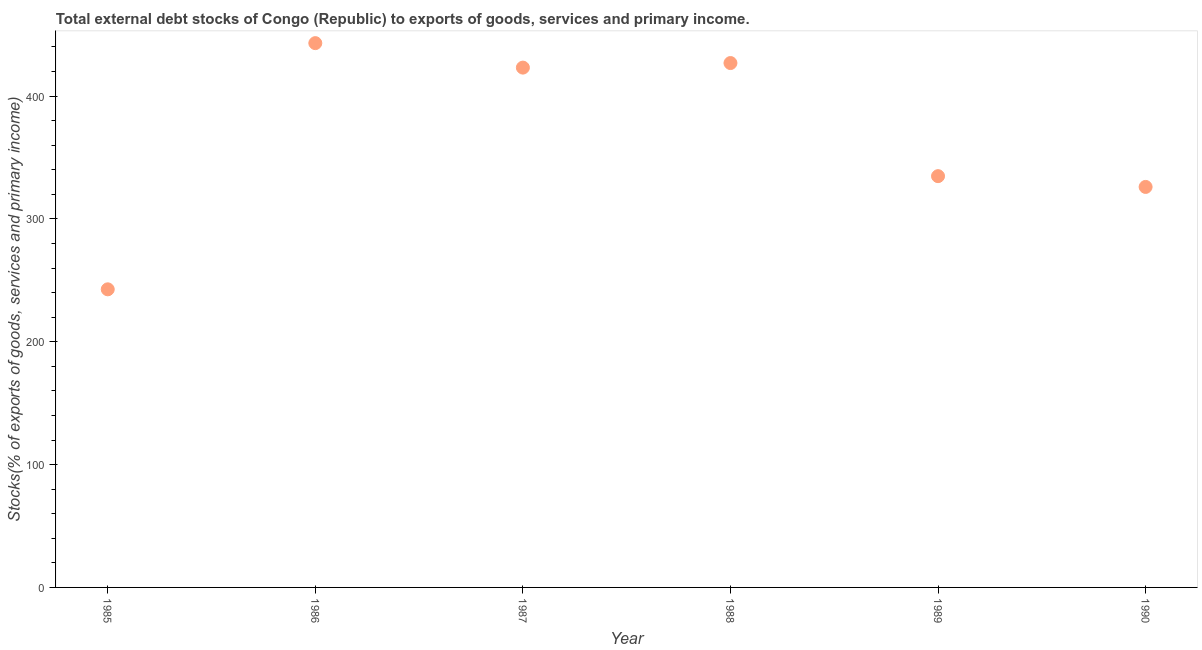What is the external debt stocks in 1990?
Your answer should be very brief. 326.01. Across all years, what is the maximum external debt stocks?
Your answer should be compact. 443.06. Across all years, what is the minimum external debt stocks?
Ensure brevity in your answer.  242.66. In which year was the external debt stocks maximum?
Offer a terse response. 1986. What is the sum of the external debt stocks?
Offer a terse response. 2196.49. What is the difference between the external debt stocks in 1987 and 1988?
Your answer should be compact. -3.71. What is the average external debt stocks per year?
Your response must be concise. 366.08. What is the median external debt stocks?
Keep it short and to the point. 378.96. In how many years, is the external debt stocks greater than 320 %?
Make the answer very short. 5. Do a majority of the years between 1987 and 1985 (inclusive) have external debt stocks greater than 280 %?
Make the answer very short. No. What is the ratio of the external debt stocks in 1986 to that in 1988?
Provide a short and direct response. 1.04. Is the external debt stocks in 1987 less than that in 1988?
Give a very brief answer. Yes. Is the difference between the external debt stocks in 1986 and 1988 greater than the difference between any two years?
Your answer should be compact. No. What is the difference between the highest and the second highest external debt stocks?
Provide a succinct answer. 16.21. What is the difference between the highest and the lowest external debt stocks?
Provide a succinct answer. 200.4. In how many years, is the external debt stocks greater than the average external debt stocks taken over all years?
Provide a short and direct response. 3. How many dotlines are there?
Offer a terse response. 1. What is the difference between two consecutive major ticks on the Y-axis?
Keep it short and to the point. 100. Are the values on the major ticks of Y-axis written in scientific E-notation?
Ensure brevity in your answer.  No. Does the graph contain grids?
Keep it short and to the point. No. What is the title of the graph?
Ensure brevity in your answer.  Total external debt stocks of Congo (Republic) to exports of goods, services and primary income. What is the label or title of the Y-axis?
Offer a terse response. Stocks(% of exports of goods, services and primary income). What is the Stocks(% of exports of goods, services and primary income) in 1985?
Your answer should be compact. 242.66. What is the Stocks(% of exports of goods, services and primary income) in 1986?
Your response must be concise. 443.06. What is the Stocks(% of exports of goods, services and primary income) in 1987?
Offer a terse response. 423.14. What is the Stocks(% of exports of goods, services and primary income) in 1988?
Provide a short and direct response. 426.85. What is the Stocks(% of exports of goods, services and primary income) in 1989?
Give a very brief answer. 334.79. What is the Stocks(% of exports of goods, services and primary income) in 1990?
Your answer should be compact. 326.01. What is the difference between the Stocks(% of exports of goods, services and primary income) in 1985 and 1986?
Your answer should be compact. -200.4. What is the difference between the Stocks(% of exports of goods, services and primary income) in 1985 and 1987?
Provide a short and direct response. -180.48. What is the difference between the Stocks(% of exports of goods, services and primary income) in 1985 and 1988?
Keep it short and to the point. -184.19. What is the difference between the Stocks(% of exports of goods, services and primary income) in 1985 and 1989?
Give a very brief answer. -92.13. What is the difference between the Stocks(% of exports of goods, services and primary income) in 1985 and 1990?
Keep it short and to the point. -83.35. What is the difference between the Stocks(% of exports of goods, services and primary income) in 1986 and 1987?
Your answer should be compact. 19.92. What is the difference between the Stocks(% of exports of goods, services and primary income) in 1986 and 1988?
Your answer should be compact. 16.21. What is the difference between the Stocks(% of exports of goods, services and primary income) in 1986 and 1989?
Ensure brevity in your answer.  108.27. What is the difference between the Stocks(% of exports of goods, services and primary income) in 1986 and 1990?
Your response must be concise. 117.05. What is the difference between the Stocks(% of exports of goods, services and primary income) in 1987 and 1988?
Ensure brevity in your answer.  -3.71. What is the difference between the Stocks(% of exports of goods, services and primary income) in 1987 and 1989?
Provide a succinct answer. 88.35. What is the difference between the Stocks(% of exports of goods, services and primary income) in 1987 and 1990?
Your answer should be very brief. 97.13. What is the difference between the Stocks(% of exports of goods, services and primary income) in 1988 and 1989?
Provide a succinct answer. 92.06. What is the difference between the Stocks(% of exports of goods, services and primary income) in 1988 and 1990?
Keep it short and to the point. 100.84. What is the difference between the Stocks(% of exports of goods, services and primary income) in 1989 and 1990?
Keep it short and to the point. 8.78. What is the ratio of the Stocks(% of exports of goods, services and primary income) in 1985 to that in 1986?
Ensure brevity in your answer.  0.55. What is the ratio of the Stocks(% of exports of goods, services and primary income) in 1985 to that in 1987?
Provide a succinct answer. 0.57. What is the ratio of the Stocks(% of exports of goods, services and primary income) in 1985 to that in 1988?
Your response must be concise. 0.57. What is the ratio of the Stocks(% of exports of goods, services and primary income) in 1985 to that in 1989?
Give a very brief answer. 0.72. What is the ratio of the Stocks(% of exports of goods, services and primary income) in 1985 to that in 1990?
Keep it short and to the point. 0.74. What is the ratio of the Stocks(% of exports of goods, services and primary income) in 1986 to that in 1987?
Give a very brief answer. 1.05. What is the ratio of the Stocks(% of exports of goods, services and primary income) in 1986 to that in 1988?
Keep it short and to the point. 1.04. What is the ratio of the Stocks(% of exports of goods, services and primary income) in 1986 to that in 1989?
Provide a succinct answer. 1.32. What is the ratio of the Stocks(% of exports of goods, services and primary income) in 1986 to that in 1990?
Give a very brief answer. 1.36. What is the ratio of the Stocks(% of exports of goods, services and primary income) in 1987 to that in 1988?
Provide a succinct answer. 0.99. What is the ratio of the Stocks(% of exports of goods, services and primary income) in 1987 to that in 1989?
Your answer should be very brief. 1.26. What is the ratio of the Stocks(% of exports of goods, services and primary income) in 1987 to that in 1990?
Offer a very short reply. 1.3. What is the ratio of the Stocks(% of exports of goods, services and primary income) in 1988 to that in 1989?
Keep it short and to the point. 1.27. What is the ratio of the Stocks(% of exports of goods, services and primary income) in 1988 to that in 1990?
Make the answer very short. 1.31. 